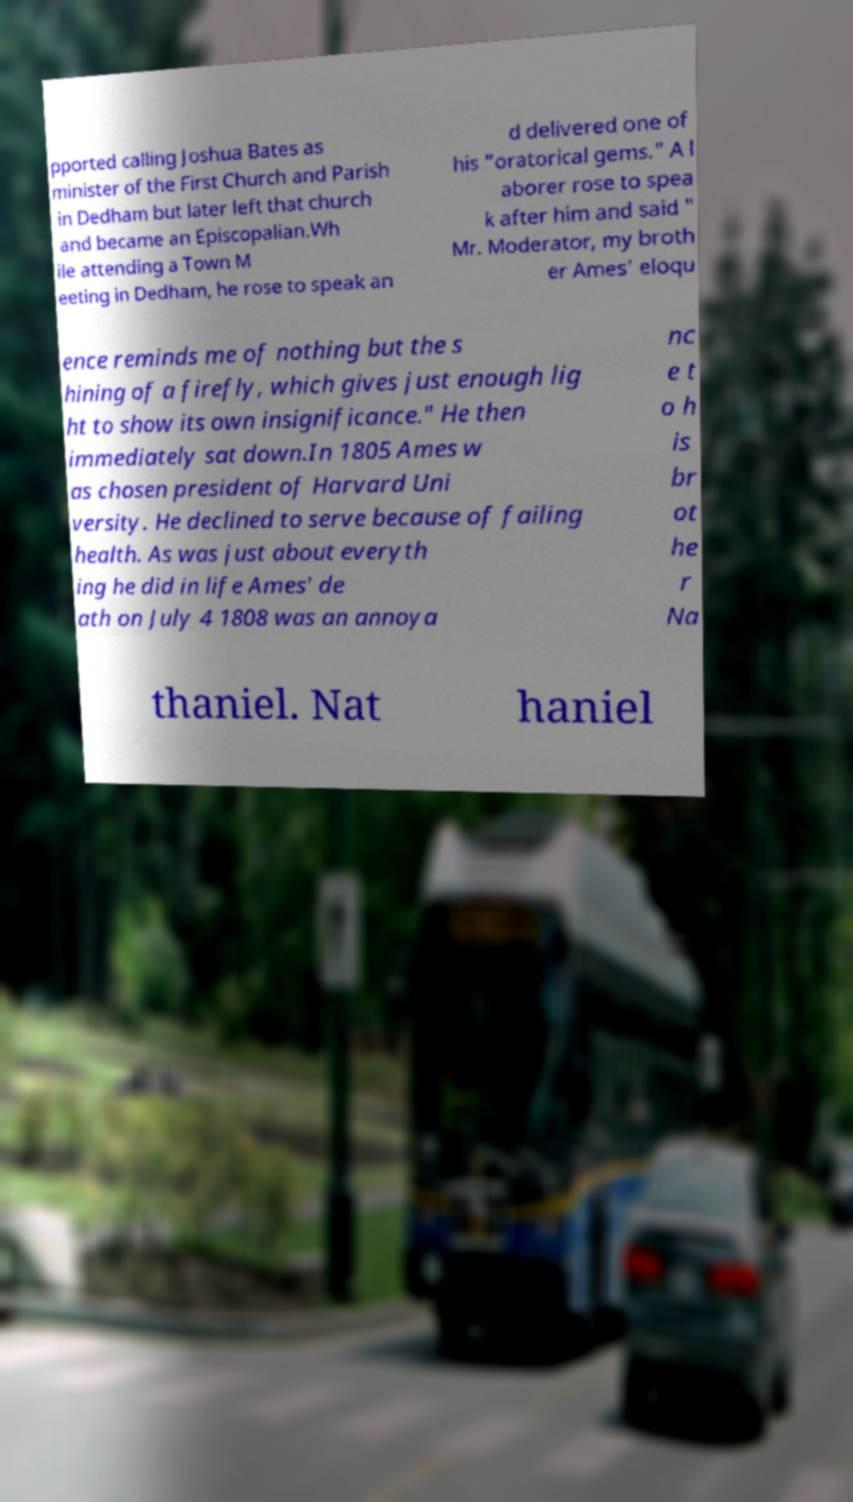There's text embedded in this image that I need extracted. Can you transcribe it verbatim? pported calling Joshua Bates as minister of the First Church and Parish in Dedham but later left that church and became an Episcopalian.Wh ile attending a Town M eeting in Dedham, he rose to speak an d delivered one of his "oratorical gems." A l aborer rose to spea k after him and said " Mr. Moderator, my broth er Ames' eloqu ence reminds me of nothing but the s hining of a firefly, which gives just enough lig ht to show its own insignificance." He then immediately sat down.In 1805 Ames w as chosen president of Harvard Uni versity. He declined to serve because of failing health. As was just about everyth ing he did in life Ames' de ath on July 4 1808 was an annoya nc e t o h is br ot he r Na thaniel. Nat haniel 